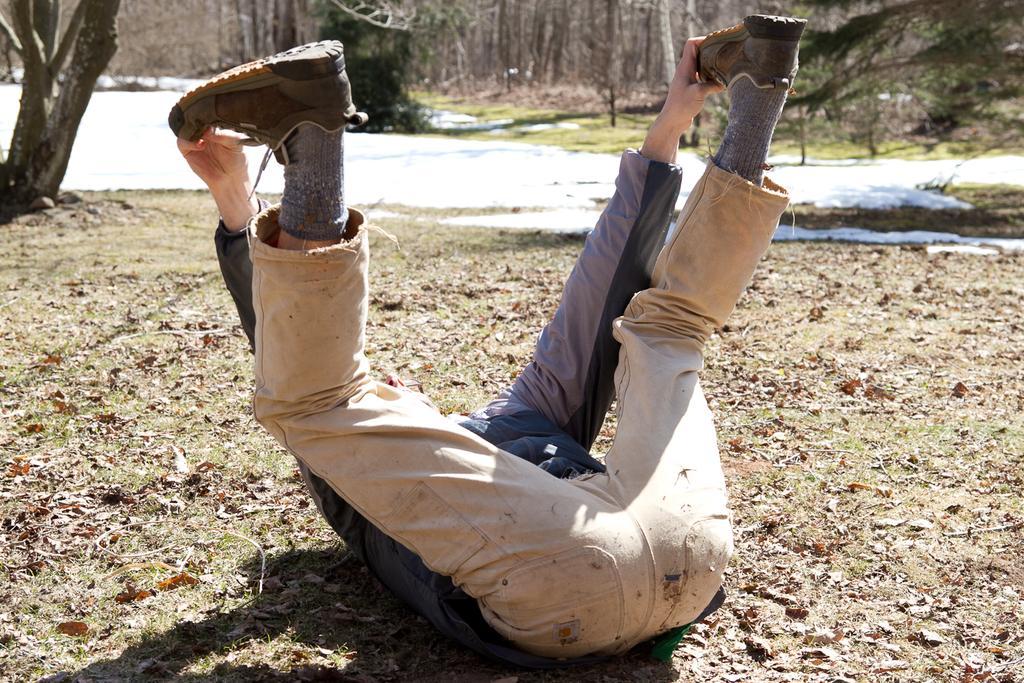Can you describe this image briefly? In this picture there is a person lying and holding the legs. At the back there are trees. At the bottom there is grass and there are dried leaves and there is a white color object. 